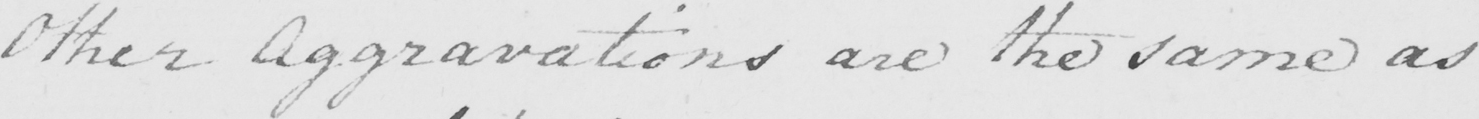Please provide the text content of this handwritten line. Other Aggravations are the same as 